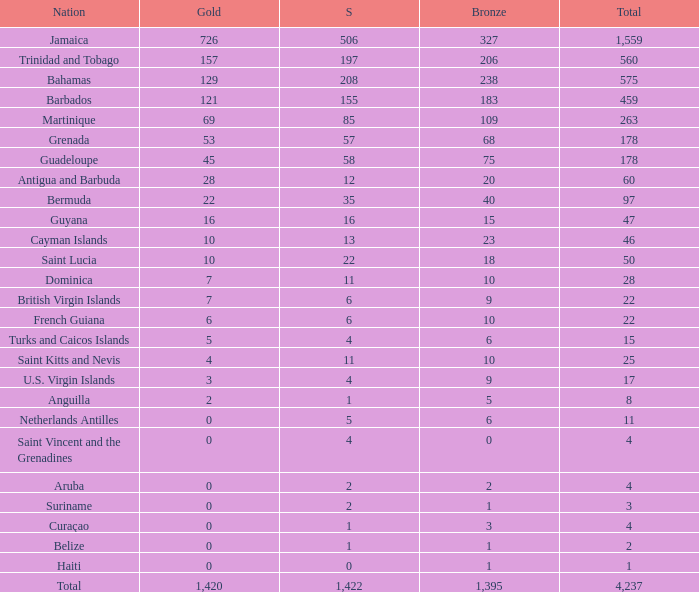What Nation has a Bronze that is smaller than 10 with a Silver of 5? Netherlands Antilles. 